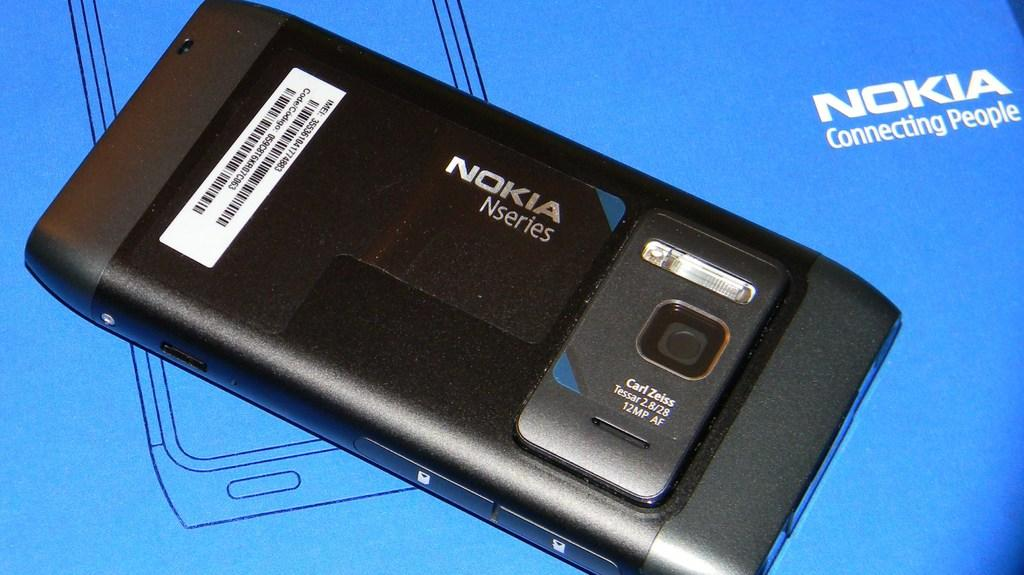<image>
Give a short and clear explanation of the subsequent image. Nokia Nseries phone and box that connects people 